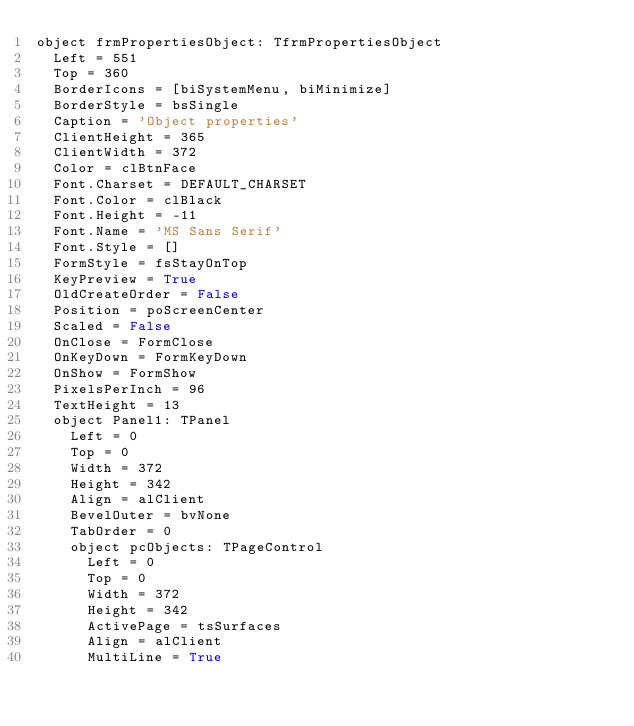Convert code to text. <code><loc_0><loc_0><loc_500><loc_500><_Pascal_>object frmPropertiesObject: TfrmPropertiesObject
  Left = 551
  Top = 360
  BorderIcons = [biSystemMenu, biMinimize]
  BorderStyle = bsSingle
  Caption = 'Object properties'
  ClientHeight = 365
  ClientWidth = 372
  Color = clBtnFace
  Font.Charset = DEFAULT_CHARSET
  Font.Color = clBlack
  Font.Height = -11
  Font.Name = 'MS Sans Serif'
  Font.Style = []
  FormStyle = fsStayOnTop
  KeyPreview = True
  OldCreateOrder = False
  Position = poScreenCenter
  Scaled = False
  OnClose = FormClose
  OnKeyDown = FormKeyDown
  OnShow = FormShow
  PixelsPerInch = 96
  TextHeight = 13
  object Panel1: TPanel
    Left = 0
    Top = 0
    Width = 372
    Height = 342
    Align = alClient
    BevelOuter = bvNone
    TabOrder = 0
    object pcObjects: TPageControl
      Left = 0
      Top = 0
      Width = 372
      Height = 342
      ActivePage = tsSurfaces
      Align = alClient
      MultiLine = True</code> 